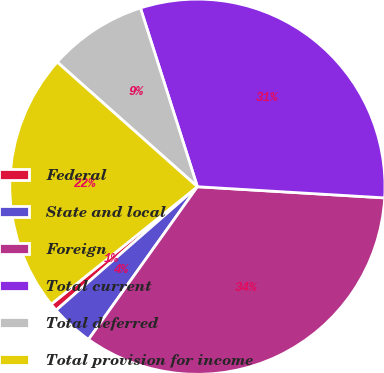Convert chart to OTSL. <chart><loc_0><loc_0><loc_500><loc_500><pie_chart><fcel>Federal<fcel>State and local<fcel>Foreign<fcel>Total current<fcel>Total deferred<fcel>Total provision for income<nl><fcel>0.66%<fcel>3.71%<fcel>33.91%<fcel>30.86%<fcel>8.52%<fcel>22.34%<nl></chart> 